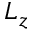<formula> <loc_0><loc_0><loc_500><loc_500>L _ { z }</formula> 